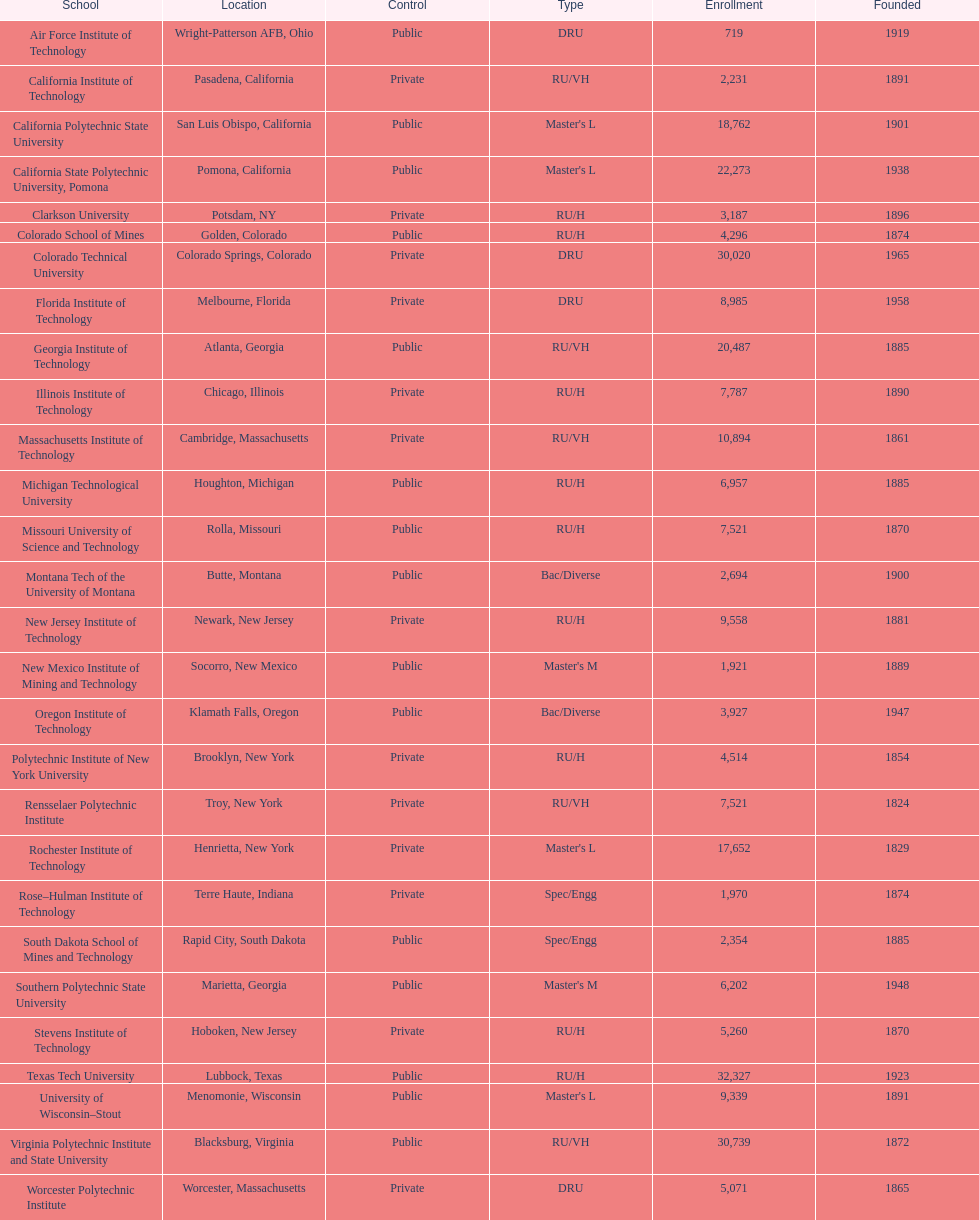Which of the higher education institutions was founded earliest? Rensselaer Polytechnic Institute. 